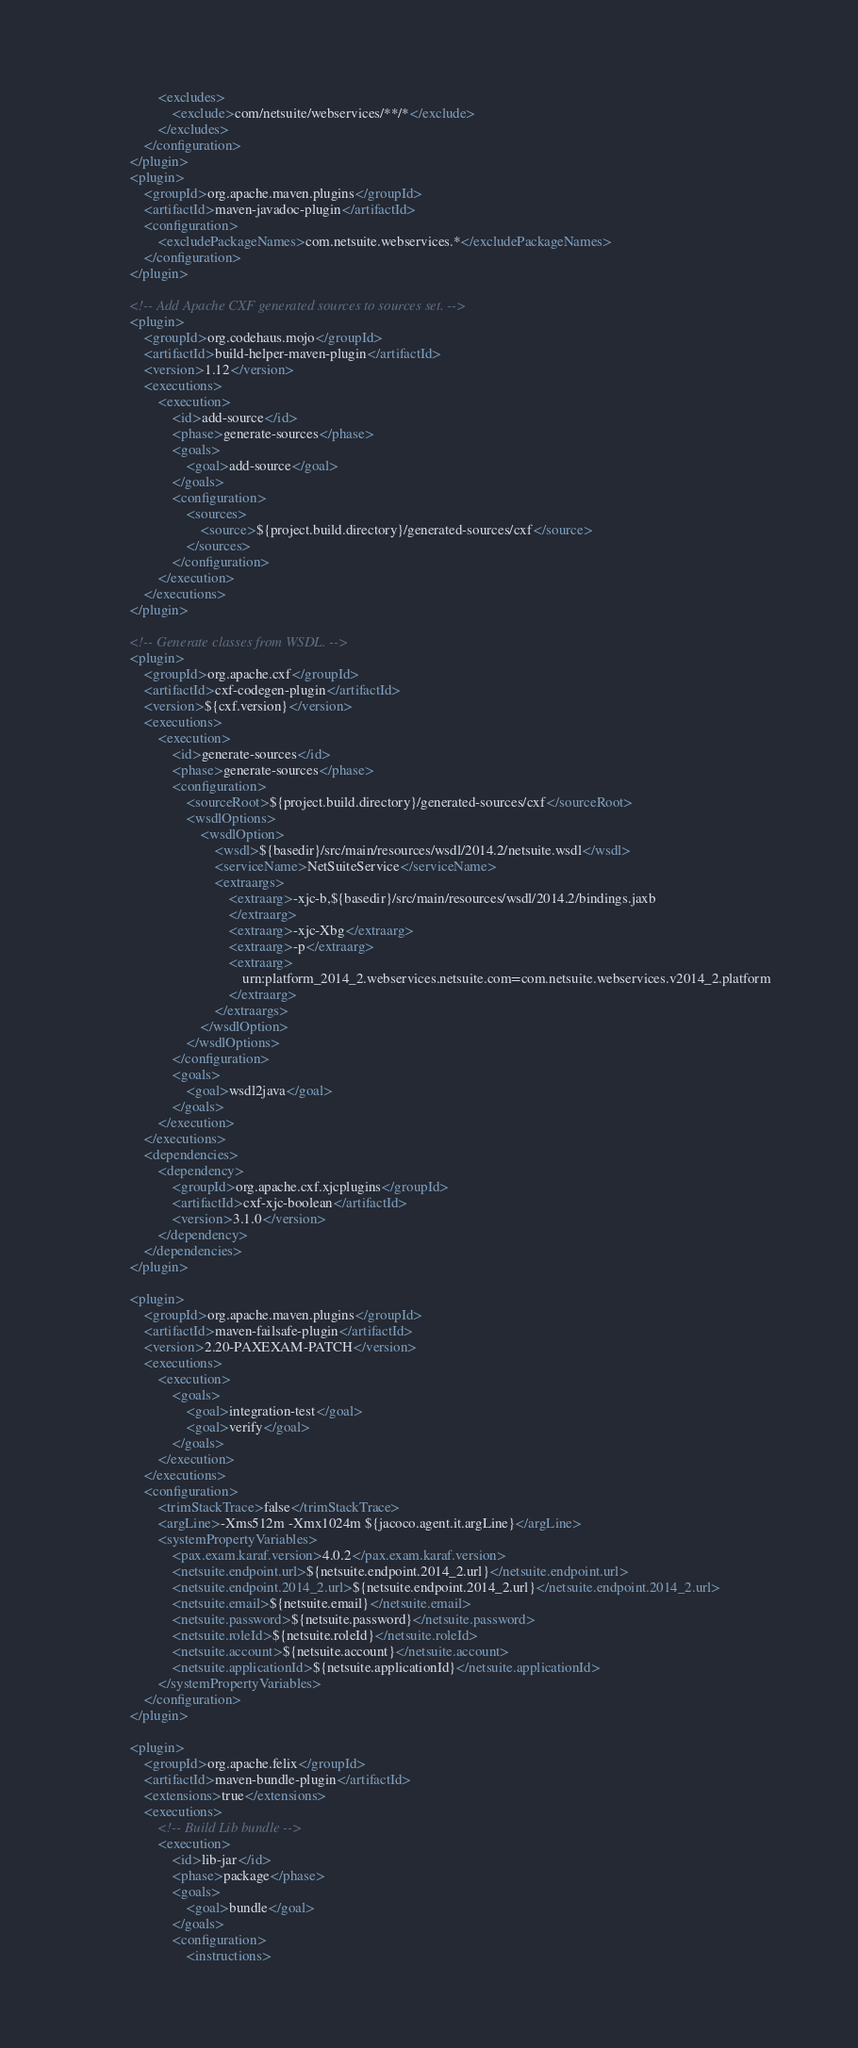<code> <loc_0><loc_0><loc_500><loc_500><_XML_>                    <excludes>
                        <exclude>com/netsuite/webservices/**/*</exclude>
                    </excludes>
                </configuration>
            </plugin>
            <plugin>
                <groupId>org.apache.maven.plugins</groupId>
                <artifactId>maven-javadoc-plugin</artifactId>
                <configuration>
                    <excludePackageNames>com.netsuite.webservices.*</excludePackageNames>
                </configuration>
            </plugin>

            <!-- Add Apache CXF generated sources to sources set. -->
            <plugin>
                <groupId>org.codehaus.mojo</groupId>
                <artifactId>build-helper-maven-plugin</artifactId>
                <version>1.12</version>
                <executions>
                    <execution>
                        <id>add-source</id>
                        <phase>generate-sources</phase>
                        <goals>
                            <goal>add-source</goal>
                        </goals>
                        <configuration>
                            <sources>
                                <source>${project.build.directory}/generated-sources/cxf</source>
                            </sources>
                        </configuration>
                    </execution>
                </executions>
            </plugin>

            <!-- Generate classes from WSDL. -->
            <plugin>
                <groupId>org.apache.cxf</groupId>
                <artifactId>cxf-codegen-plugin</artifactId>
                <version>${cxf.version}</version>
                <executions>
                    <execution>
                        <id>generate-sources</id>
                        <phase>generate-sources</phase>
                        <configuration>
                            <sourceRoot>${project.build.directory}/generated-sources/cxf</sourceRoot>
                            <wsdlOptions>
                                <wsdlOption>
                                    <wsdl>${basedir}/src/main/resources/wsdl/2014.2/netsuite.wsdl</wsdl>
                                    <serviceName>NetSuiteService</serviceName>
                                    <extraargs>
                                        <extraarg>-xjc-b,${basedir}/src/main/resources/wsdl/2014.2/bindings.jaxb
                                        </extraarg>
                                        <extraarg>-xjc-Xbg</extraarg>
                                        <extraarg>-p</extraarg>
                                        <extraarg>
                                            urn:platform_2014_2.webservices.netsuite.com=com.netsuite.webservices.v2014_2.platform
                                        </extraarg>
                                    </extraargs>
                                </wsdlOption>
                            </wsdlOptions>
                        </configuration>
                        <goals>
                            <goal>wsdl2java</goal>
                        </goals>
                    </execution>
                </executions>
                <dependencies>
                    <dependency>
                        <groupId>org.apache.cxf.xjcplugins</groupId>
                        <artifactId>cxf-xjc-boolean</artifactId>
                        <version>3.1.0</version>
                    </dependency>
                </dependencies>
            </plugin>

            <plugin>
                <groupId>org.apache.maven.plugins</groupId>
                <artifactId>maven-failsafe-plugin</artifactId>
                <version>2.20-PAXEXAM-PATCH</version>
                <executions>
                    <execution>
                        <goals>
                            <goal>integration-test</goal>
                            <goal>verify</goal>
                        </goals>
                    </execution>
                </executions>
                <configuration>
                    <trimStackTrace>false</trimStackTrace>
                    <argLine>-Xms512m -Xmx1024m ${jacoco.agent.it.argLine}</argLine>
                    <systemPropertyVariables>
                        <pax.exam.karaf.version>4.0.2</pax.exam.karaf.version>
                        <netsuite.endpoint.url>${netsuite.endpoint.2014_2.url}</netsuite.endpoint.url>
                        <netsuite.endpoint.2014_2.url>${netsuite.endpoint.2014_2.url}</netsuite.endpoint.2014_2.url>
                        <netsuite.email>${netsuite.email}</netsuite.email>
                        <netsuite.password>${netsuite.password}</netsuite.password>
                        <netsuite.roleId>${netsuite.roleId}</netsuite.roleId>
                        <netsuite.account>${netsuite.account}</netsuite.account>
                        <netsuite.applicationId>${netsuite.applicationId}</netsuite.applicationId>
                    </systemPropertyVariables>
                </configuration>
            </plugin>

            <plugin>
                <groupId>org.apache.felix</groupId>
                <artifactId>maven-bundle-plugin</artifactId>
                <extensions>true</extensions>
                <executions>
                    <!-- Build Lib bundle -->
                    <execution>
                        <id>lib-jar</id>
                        <phase>package</phase>
                        <goals>
                            <goal>bundle</goal>
                        </goals>
                        <configuration>
                            <instructions></code> 